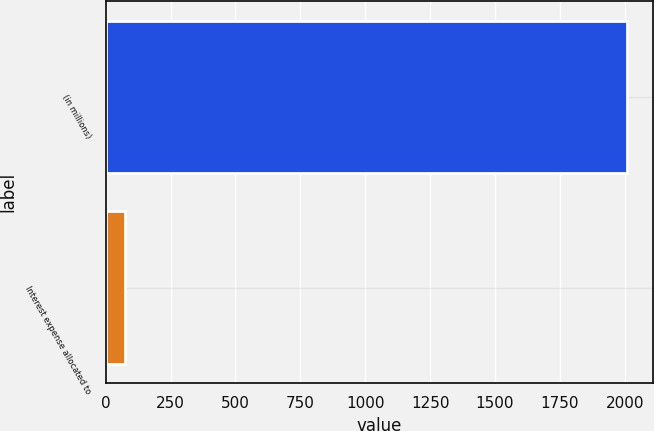Convert chart to OTSL. <chart><loc_0><loc_0><loc_500><loc_500><bar_chart><fcel>(in millions)<fcel>Interest expense allocated to<nl><fcel>2009<fcel>75.2<nl></chart> 